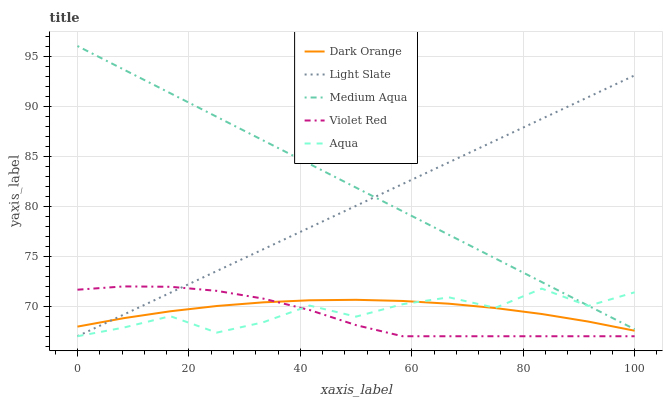Does Violet Red have the minimum area under the curve?
Answer yes or no. Yes. Does Medium Aqua have the maximum area under the curve?
Answer yes or no. Yes. Does Dark Orange have the minimum area under the curve?
Answer yes or no. No. Does Dark Orange have the maximum area under the curve?
Answer yes or no. No. Is Light Slate the smoothest?
Answer yes or no. Yes. Is Aqua the roughest?
Answer yes or no. Yes. Is Dark Orange the smoothest?
Answer yes or no. No. Is Dark Orange the roughest?
Answer yes or no. No. Does Light Slate have the lowest value?
Answer yes or no. Yes. Does Dark Orange have the lowest value?
Answer yes or no. No. Does Medium Aqua have the highest value?
Answer yes or no. Yes. Does Violet Red have the highest value?
Answer yes or no. No. Is Violet Red less than Medium Aqua?
Answer yes or no. Yes. Is Medium Aqua greater than Violet Red?
Answer yes or no. Yes. Does Aqua intersect Medium Aqua?
Answer yes or no. Yes. Is Aqua less than Medium Aqua?
Answer yes or no. No. Is Aqua greater than Medium Aqua?
Answer yes or no. No. Does Violet Red intersect Medium Aqua?
Answer yes or no. No. 